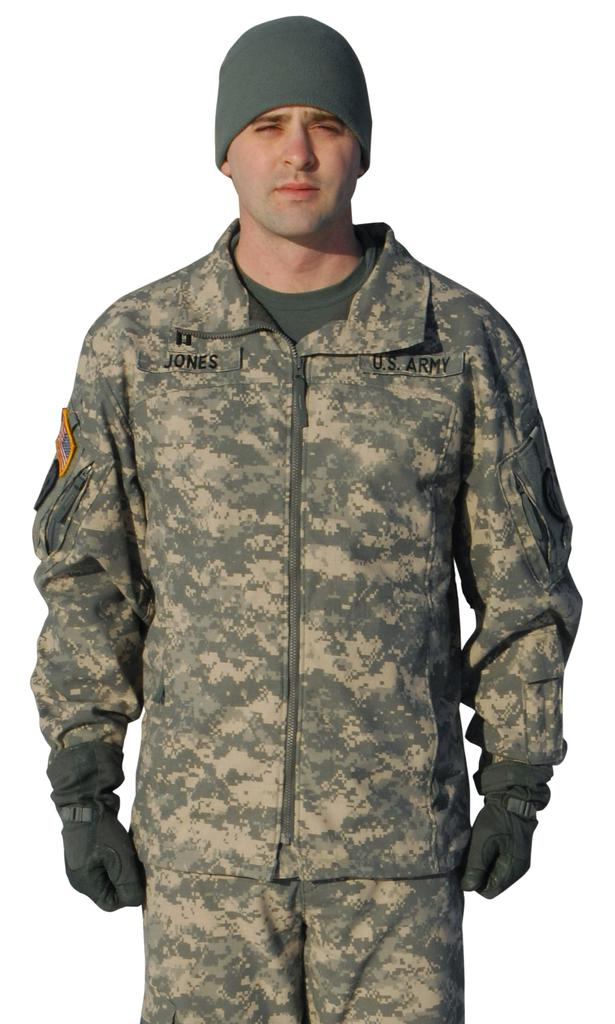What is the main subject of the image? There is a person standing in the image. Where is the person located in the image? The person is in the middle of the image. What is the person wearing on their head? The person is wearing a cap. Can you see any toys being played with by the person in the image? There are no toys visible in the image. Is the moon visible in the background of the image? The moon is not visible in the image. 